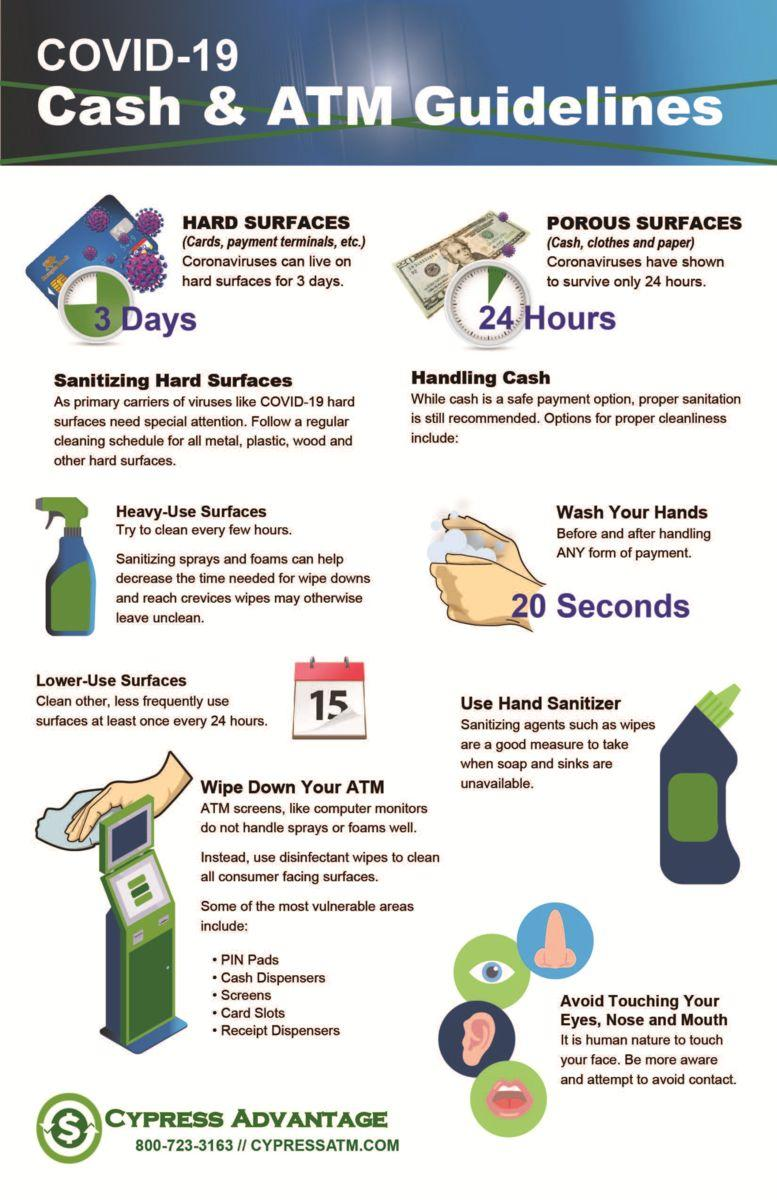Indicate a few pertinent items in this graphic. The date displayed on the calendar is October 15th. It is recommended to wash hands for at least 20 seconds in order to effectively prevent the spread of COVID-19. The COVID-19 virus can remain on porous surfaces for 24 hours. The COVID-19 virus can remain on hard surfaces for up to three days. 